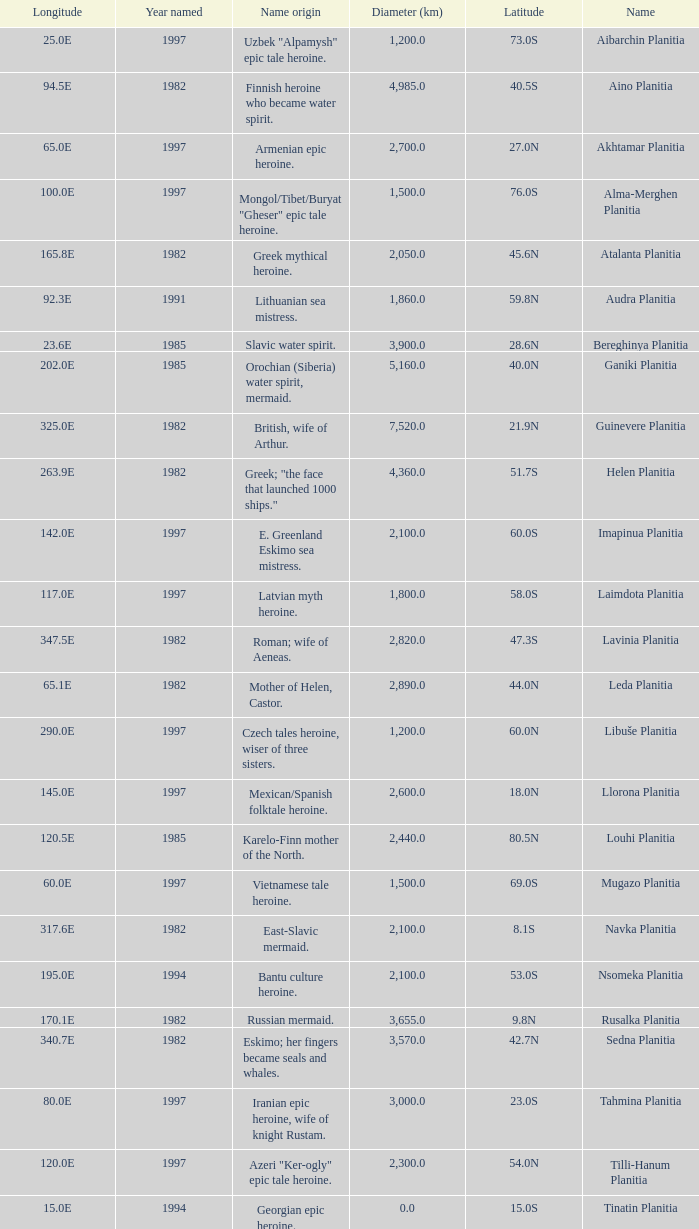What's the name origin of feature of diameter (km) 2,155.0 Karelo-Finn mermaid. 